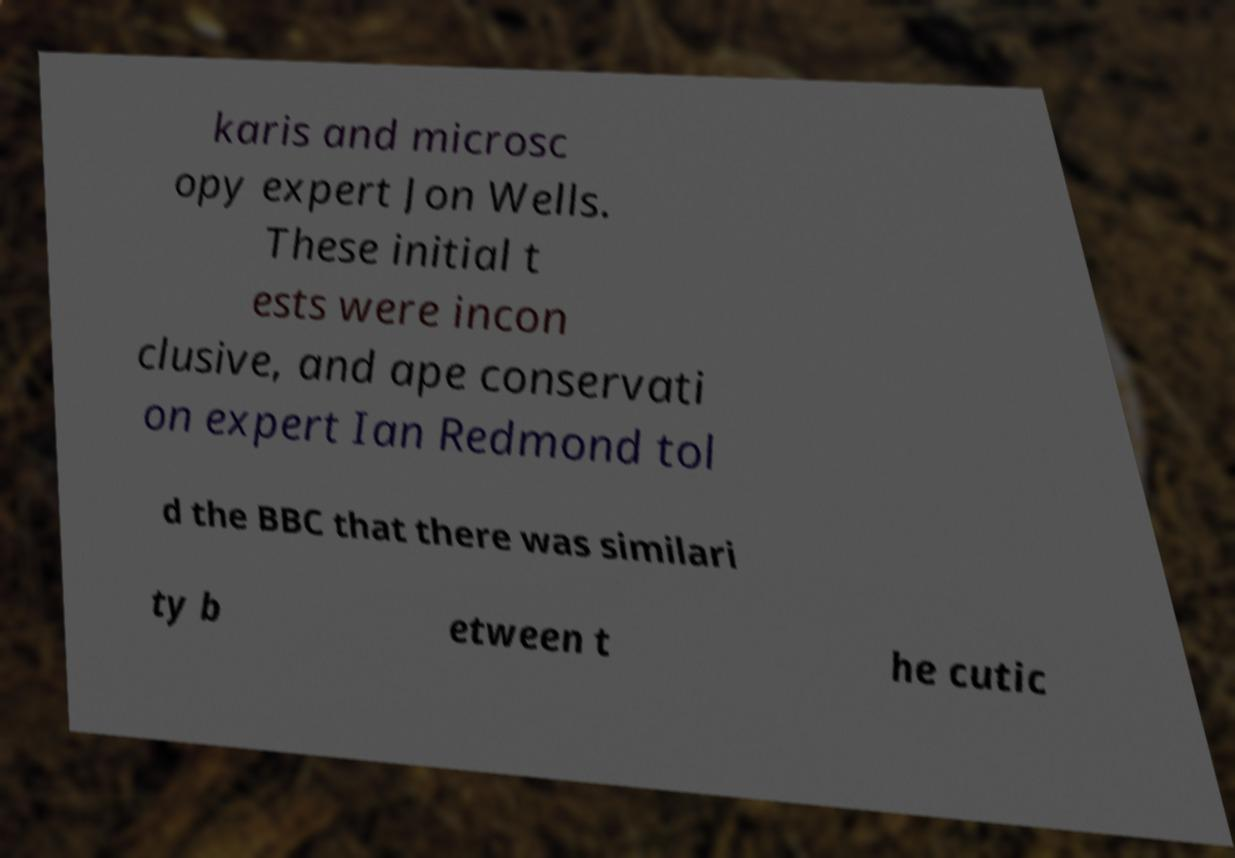I need the written content from this picture converted into text. Can you do that? karis and microsc opy expert Jon Wells. These initial t ests were incon clusive, and ape conservati on expert Ian Redmond tol d the BBC that there was similari ty b etween t he cutic 